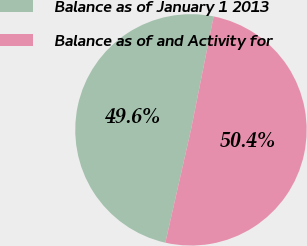<chart> <loc_0><loc_0><loc_500><loc_500><pie_chart><fcel>Balance as of January 1 2013<fcel>Balance as of and Activity for<nl><fcel>49.59%<fcel>50.41%<nl></chart> 